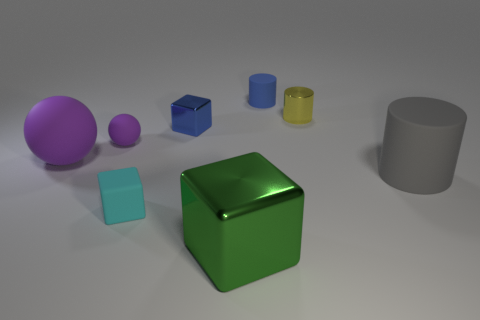There is a yellow object that is the same size as the blue metal block; what is it made of?
Offer a very short reply. Metal. Is there a tiny blue thing made of the same material as the yellow cylinder?
Provide a short and direct response. Yes. There is a tiny cyan object; is it the same shape as the shiny thing that is in front of the tiny cyan cube?
Offer a terse response. Yes. How many cubes are in front of the blue metal cube and to the left of the big green metallic block?
Provide a short and direct response. 1. Are the gray cylinder and the large object that is in front of the large gray thing made of the same material?
Provide a succinct answer. No. Are there the same number of rubber cubes behind the gray cylinder and tiny purple metal balls?
Make the answer very short. Yes. There is a small matte cylinder that is right of the rubber cube; what color is it?
Offer a terse response. Blue. What number of other objects are the same color as the small matte ball?
Make the answer very short. 1. There is a matte cylinder that is left of the gray matte cylinder; is it the same size as the large green object?
Your answer should be compact. No. What material is the tiny block behind the large gray thing?
Provide a short and direct response. Metal. 